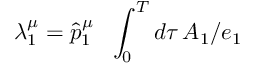<formula> <loc_0><loc_0><loc_500><loc_500>\lambda _ { 1 } ^ { \mu } = \hat { p } _ { 1 } ^ { \mu } \quad i n t _ { 0 } ^ { T } d \tau \, A _ { 1 } / e _ { 1 }</formula> 